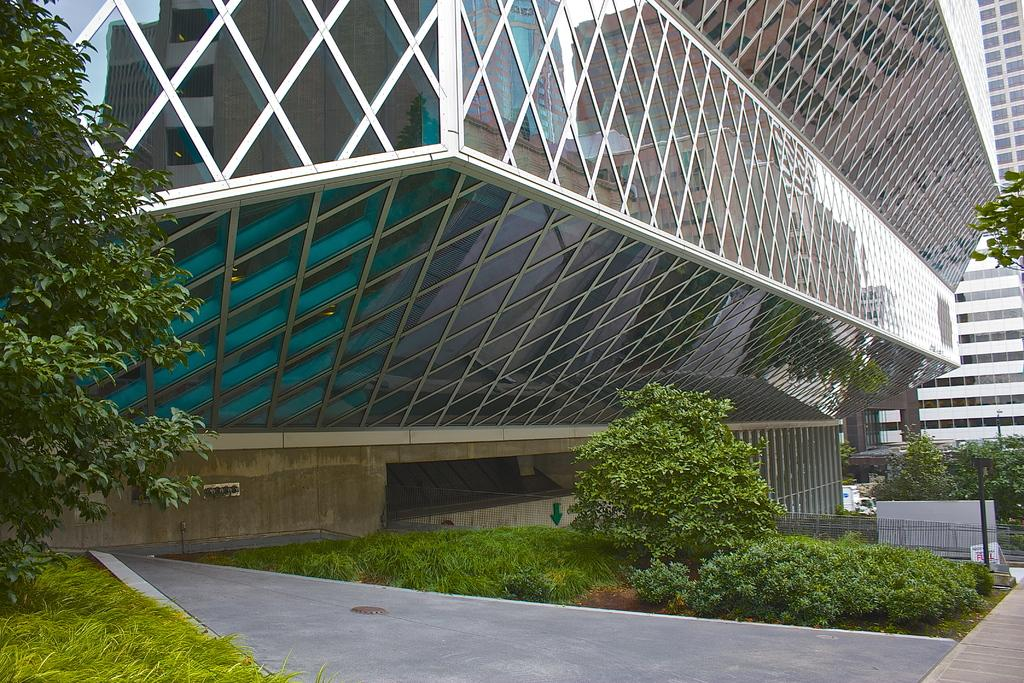What is located in the center of the image? There are buildings and trees in the center of the image. What can be seen on the poles in the image? The image does not provide information about what is on the poles. What type of structure is present in the image? There is a wall in the image. What type of ground cover is visible at the bottom of the image? There is grass and plants at the bottom of the image. What type of path is present in the image? There is a walkway in the image. What type of barrier is present in the image? There is a railing in the image. What type of competition is taking place in the image? There is no competition present in the image. What type of place is depicted in the image? The image does not provide enough information to determine the type of place depicted. 